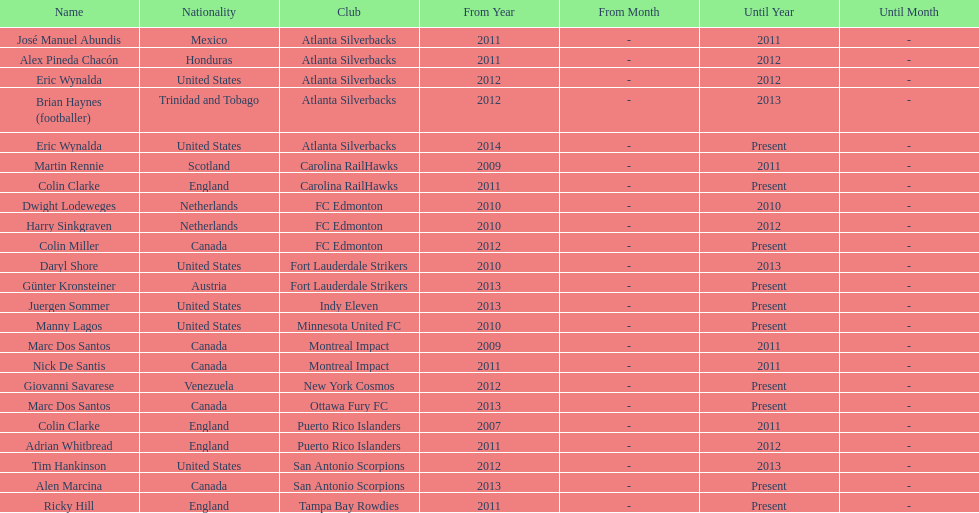Who was the coach of fc edmonton before miller? Harry Sinkgraven. Would you be able to parse every entry in this table? {'header': ['Name', 'Nationality', 'Club', 'From Year', 'From Month', 'Until Year', 'Until Month'], 'rows': [['José Manuel Abundis', 'Mexico', 'Atlanta Silverbacks', '2011', '-', '2011', '-'], ['Alex Pineda Chacón', 'Honduras', 'Atlanta Silverbacks', '2011', '-', '2012', '-'], ['Eric Wynalda', 'United States', 'Atlanta Silverbacks', '2012', '-', '2012', '-'], ['Brian Haynes (footballer)', 'Trinidad and Tobago', 'Atlanta Silverbacks', '2012', '-', '2013', '-'], ['Eric Wynalda', 'United States', 'Atlanta Silverbacks', '2014', '-', 'Present', '-'], ['Martin Rennie', 'Scotland', 'Carolina RailHawks', '2009', '-', '2011', '-'], ['Colin Clarke', 'England', 'Carolina RailHawks', '2011', '-', 'Present', '-'], ['Dwight Lodeweges', 'Netherlands', 'FC Edmonton', '2010', '-', '2010', '-'], ['Harry Sinkgraven', 'Netherlands', 'FC Edmonton', '2010', '-', '2012', '-'], ['Colin Miller', 'Canada', 'FC Edmonton', '2012', '-', 'Present', '-'], ['Daryl Shore', 'United States', 'Fort Lauderdale Strikers', '2010', '-', '2013', '-'], ['Günter Kronsteiner', 'Austria', 'Fort Lauderdale Strikers', '2013', '-', 'Present', '-'], ['Juergen Sommer', 'United States', 'Indy Eleven', '2013', '-', 'Present', '-'], ['Manny Lagos', 'United States', 'Minnesota United FC', '2010', '-', 'Present', '-'], ['Marc Dos Santos', 'Canada', 'Montreal Impact', '2009', '-', '2011', '-'], ['Nick De Santis', 'Canada', 'Montreal Impact', '2011', '-', '2011', '-'], ['Giovanni Savarese', 'Venezuela', 'New York Cosmos', '2012', '-', 'Present', '-'], ['Marc Dos Santos', 'Canada', 'Ottawa Fury FC', '2013', '-', 'Present', '-'], ['Colin Clarke', 'England', 'Puerto Rico Islanders', '2007', '-', '2011', '-'], ['Adrian Whitbread', 'England', 'Puerto Rico Islanders', '2011', '-', '2012', '-'], ['Tim Hankinson', 'United States', 'San Antonio Scorpions', '2012', '-', '2013', '-'], ['Alen Marcina', 'Canada', 'San Antonio Scorpions', '2013', '-', 'Present', '-'], ['Ricky Hill', 'England', 'Tampa Bay Rowdies', '2011', '-', 'Present', '-']]} 